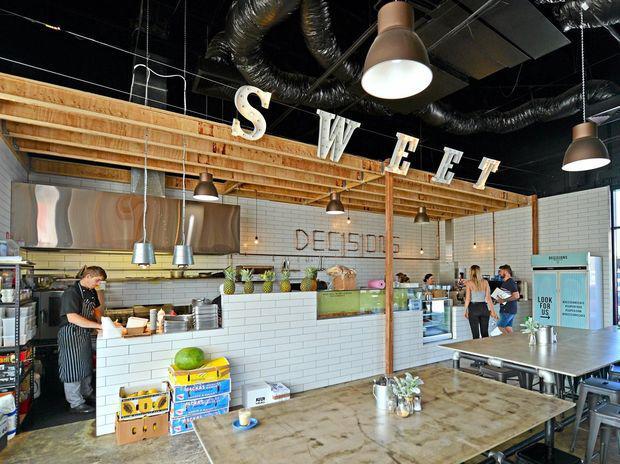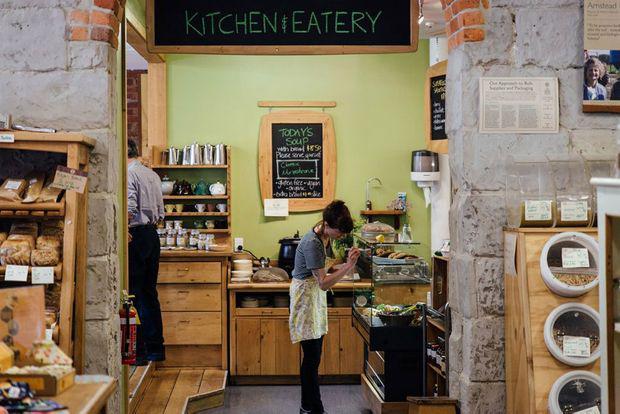The first image is the image on the left, the second image is the image on the right. Analyze the images presented: Is the assertion "In at least one image, there is a total of two people." valid? Answer yes or no. Yes. The first image is the image on the left, the second image is the image on the right. Examine the images to the left and right. Is the description "There are people sitting." accurate? Answer yes or no. No. 